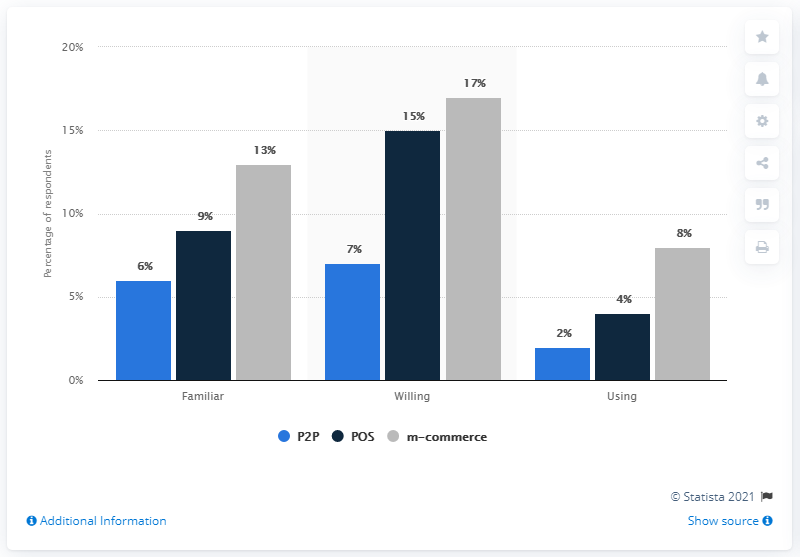Outline some significant characteristics in this image. The lowest value of grey is 8. The difference between the highest and the lowest dark blue bar in the graph is 11. 